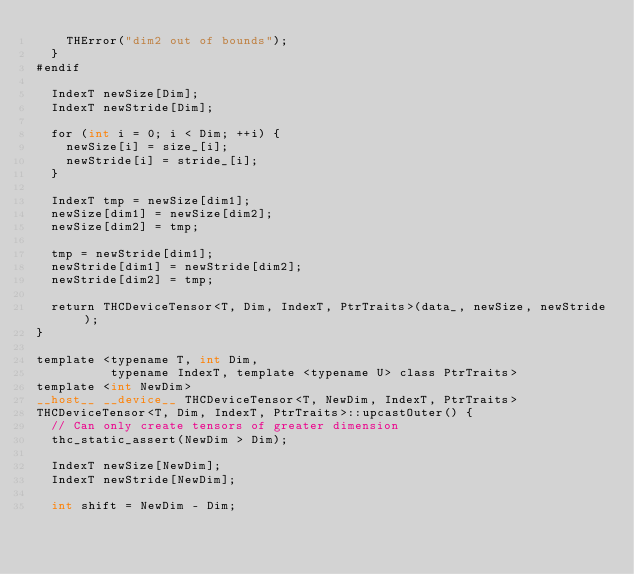<code> <loc_0><loc_0><loc_500><loc_500><_Cuda_>    THError("dim2 out of bounds");
  }
#endif

  IndexT newSize[Dim];
  IndexT newStride[Dim];

  for (int i = 0; i < Dim; ++i) {
    newSize[i] = size_[i];
    newStride[i] = stride_[i];
  }

  IndexT tmp = newSize[dim1];
  newSize[dim1] = newSize[dim2];
  newSize[dim2] = tmp;

  tmp = newStride[dim1];
  newStride[dim1] = newStride[dim2];
  newStride[dim2] = tmp;

  return THCDeviceTensor<T, Dim, IndexT, PtrTraits>(data_, newSize, newStride);
}

template <typename T, int Dim,
          typename IndexT, template <typename U> class PtrTraits>
template <int NewDim>
__host__ __device__ THCDeviceTensor<T, NewDim, IndexT, PtrTraits>
THCDeviceTensor<T, Dim, IndexT, PtrTraits>::upcastOuter() {
  // Can only create tensors of greater dimension
  thc_static_assert(NewDim > Dim);

  IndexT newSize[NewDim];
  IndexT newStride[NewDim];

  int shift = NewDim - Dim;
</code> 